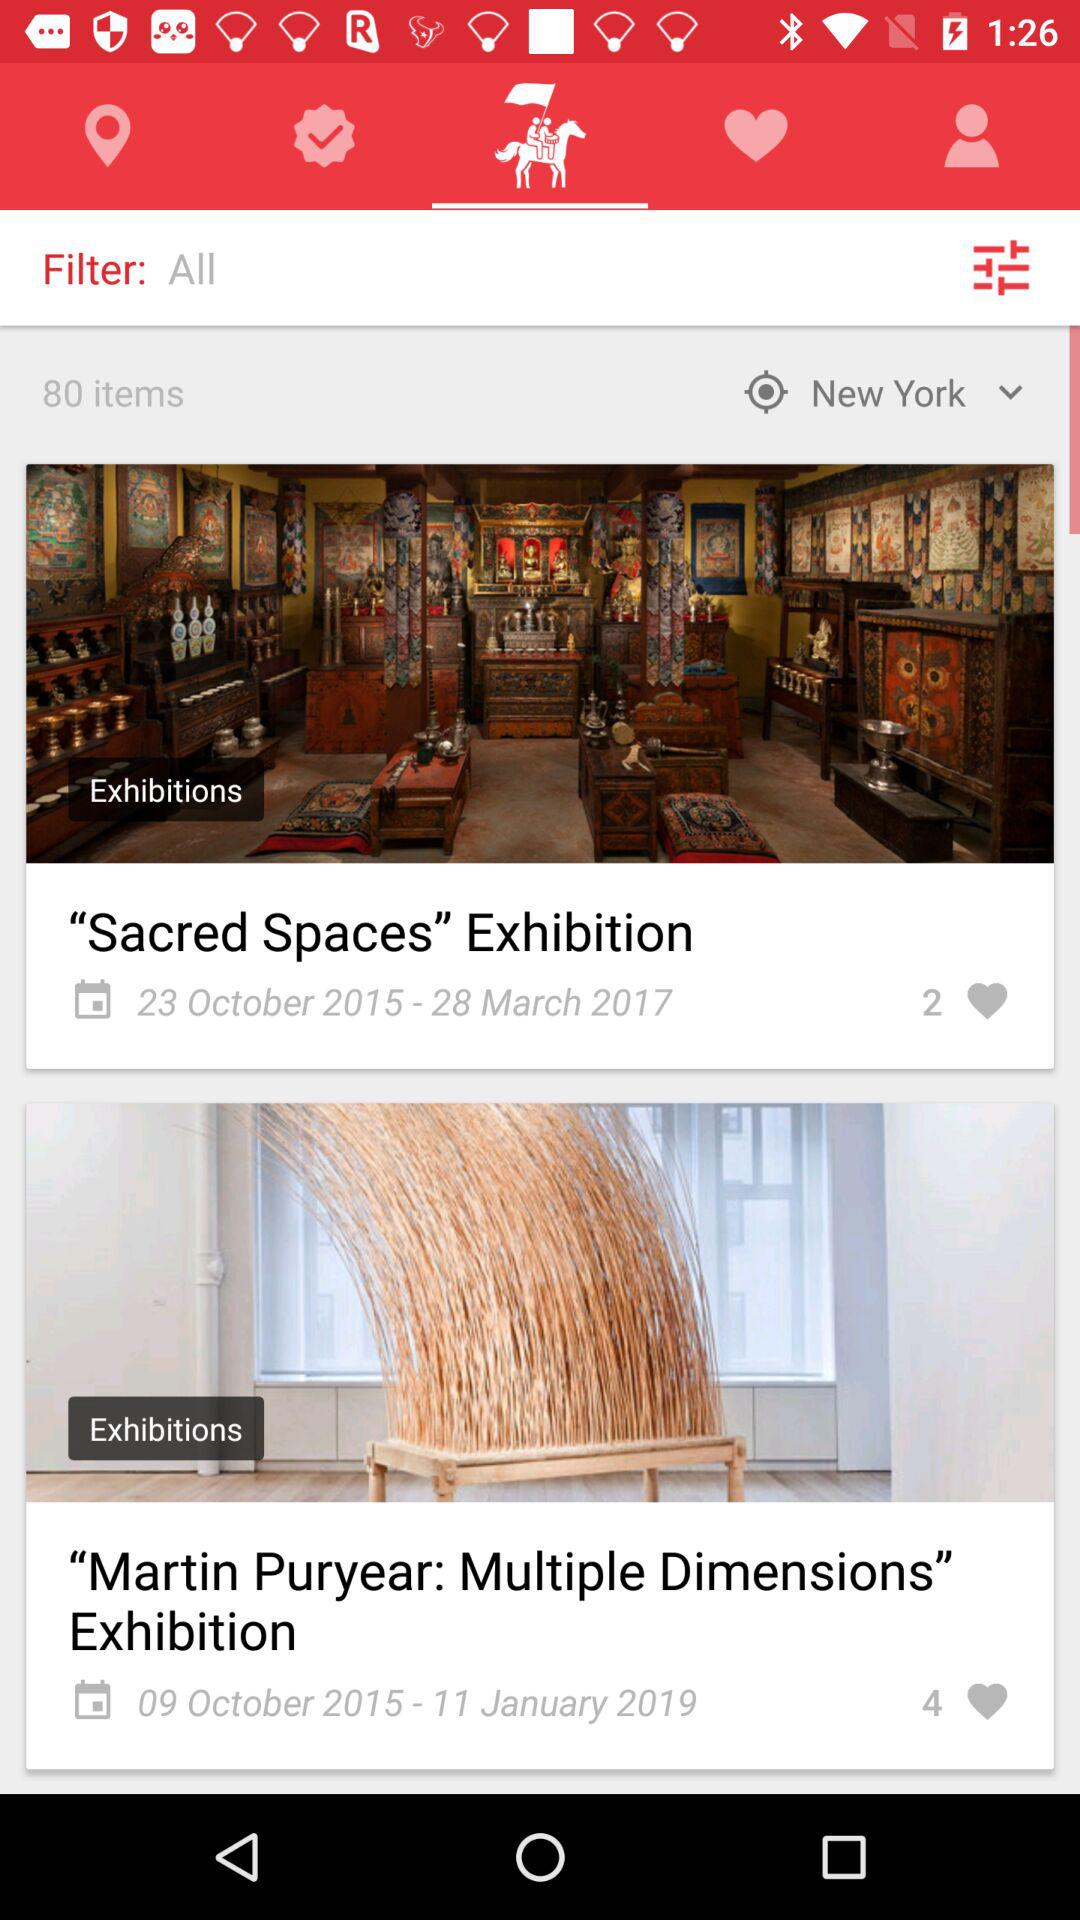What is the date of the "Sacred Spaces" exhibition? The dates of the exhibition are from October 23, 2015 to March 28, 2017. 